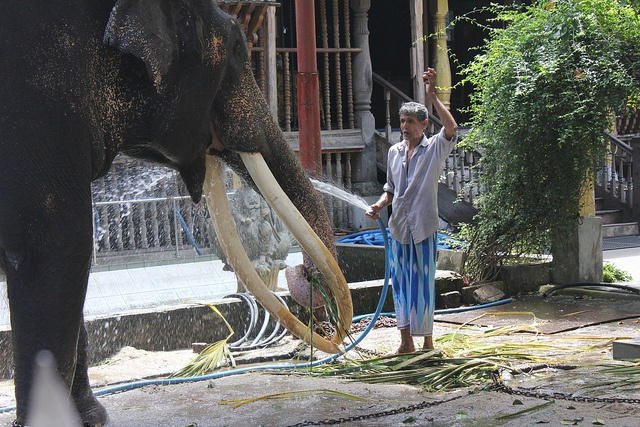Describe the objects in this image and their specific colors. I can see elephant in black, gray, and darkgray tones and people in black, gray, and navy tones in this image. 